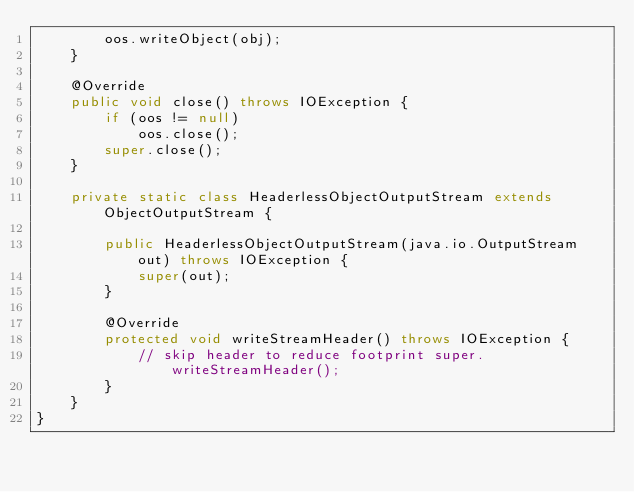<code> <loc_0><loc_0><loc_500><loc_500><_Java_>        oos.writeObject(obj);
    }

    @Override
    public void close() throws IOException {
        if (oos != null)
            oos.close();
        super.close();
    }

    private static class HeaderlessObjectOutputStream extends ObjectOutputStream {

        public HeaderlessObjectOutputStream(java.io.OutputStream out) throws IOException {
            super(out);
        }

        @Override
        protected void writeStreamHeader() throws IOException {
            // skip header to reduce footprint super.writeStreamHeader();
        }
    }
}




















































</code> 